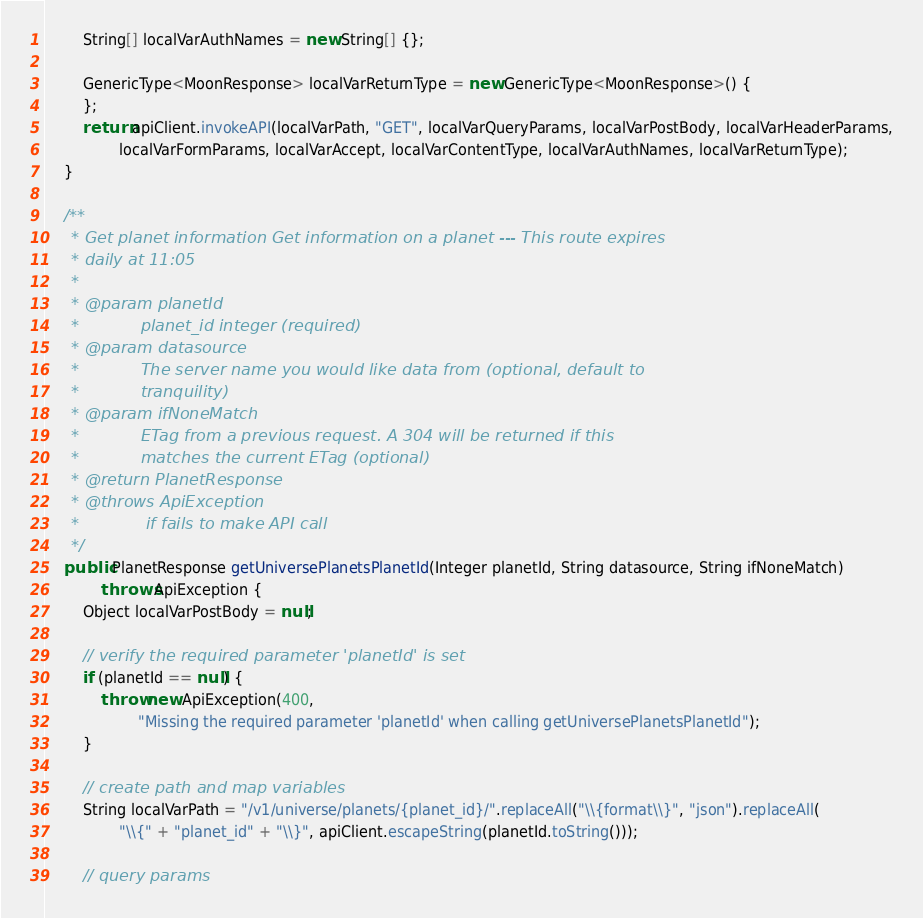<code> <loc_0><loc_0><loc_500><loc_500><_Java_>        String[] localVarAuthNames = new String[] {};

        GenericType<MoonResponse> localVarReturnType = new GenericType<MoonResponse>() {
        };
        return apiClient.invokeAPI(localVarPath, "GET", localVarQueryParams, localVarPostBody, localVarHeaderParams,
                localVarFormParams, localVarAccept, localVarContentType, localVarAuthNames, localVarReturnType);
    }

    /**
     * Get planet information Get information on a planet --- This route expires
     * daily at 11:05
     * 
     * @param planetId
     *            planet_id integer (required)
     * @param datasource
     *            The server name you would like data from (optional, default to
     *            tranquility)
     * @param ifNoneMatch
     *            ETag from a previous request. A 304 will be returned if this
     *            matches the current ETag (optional)
     * @return PlanetResponse
     * @throws ApiException
     *             if fails to make API call
     */
    public PlanetResponse getUniversePlanetsPlanetId(Integer planetId, String datasource, String ifNoneMatch)
            throws ApiException {
        Object localVarPostBody = null;

        // verify the required parameter 'planetId' is set
        if (planetId == null) {
            throw new ApiException(400,
                    "Missing the required parameter 'planetId' when calling getUniversePlanetsPlanetId");
        }

        // create path and map variables
        String localVarPath = "/v1/universe/planets/{planet_id}/".replaceAll("\\{format\\}", "json").replaceAll(
                "\\{" + "planet_id" + "\\}", apiClient.escapeString(planetId.toString()));

        // query params</code> 